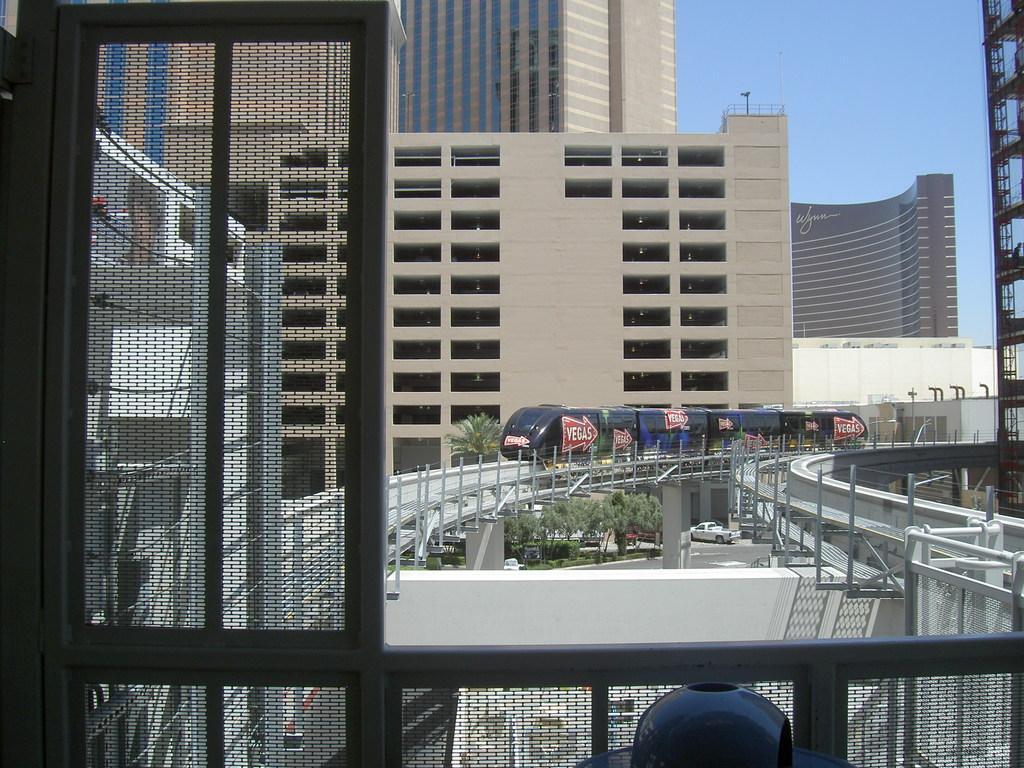How would you summarize this image in a sentence or two? In this picture we can observe a train on the railway track. There are some trees and buildings. We can observe some vehicles on the road. In the background there is a sky. 